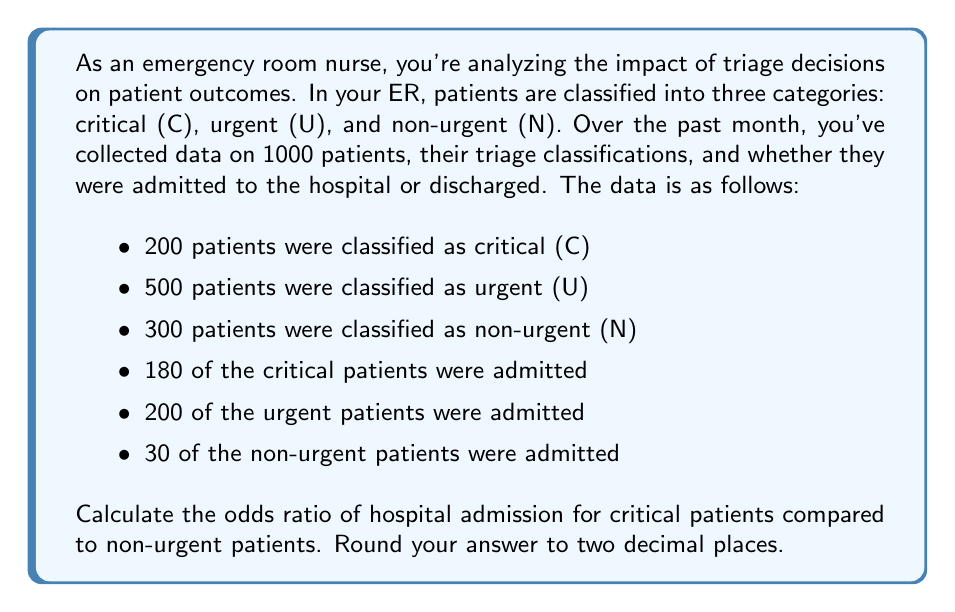Can you solve this math problem? To calculate the odds ratio, we need to follow these steps:

1. Calculate the odds of admission for critical patients:
   $$\text{Odds}_C = \frac{P(\text{Admitted}|\text{Critical})}{P(\text{Not Admitted}|\text{Critical})} = \frac{180/200}{20/200} = \frac{180}{20} = 9$$

2. Calculate the odds of admission for non-urgent patients:
   $$\text{Odds}_N = \frac{P(\text{Admitted}|\text{Non-urgent})}{P(\text{Not Admitted}|\text{Non-urgent})} = \frac{30/300}{270/300} = \frac{30}{270} = \frac{1}{9}$$

3. Calculate the odds ratio:
   $$\text{Odds Ratio} = \frac{\text{Odds}_C}{\text{Odds}_N} = \frac{9}{1/9} = 9 \times 9 = 81$$

The interpretation of this odds ratio is that critical patients have 81 times higher odds of being admitted to the hospital compared to non-urgent patients.

This analysis helps quantify the impact of triage decisions on patient outcomes, showing how the initial classification relates to the likelihood of hospital admission.
Answer: 81.00 